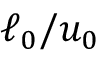Convert formula to latex. <formula><loc_0><loc_0><loc_500><loc_500>\ell _ { 0 } / u _ { 0 }</formula> 